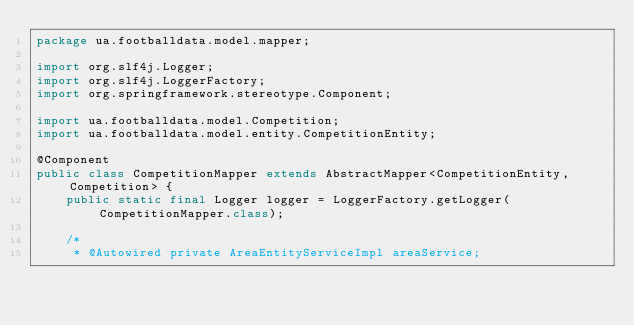Convert code to text. <code><loc_0><loc_0><loc_500><loc_500><_Java_>package ua.footballdata.model.mapper;

import org.slf4j.Logger;
import org.slf4j.LoggerFactory;
import org.springframework.stereotype.Component;

import ua.footballdata.model.Competition;
import ua.footballdata.model.entity.CompetitionEntity;

@Component
public class CompetitionMapper extends AbstractMapper<CompetitionEntity, Competition> {
	public static final Logger logger = LoggerFactory.getLogger(CompetitionMapper.class);

	/*
	 * @Autowired private AreaEntityServiceImpl areaService;</code> 